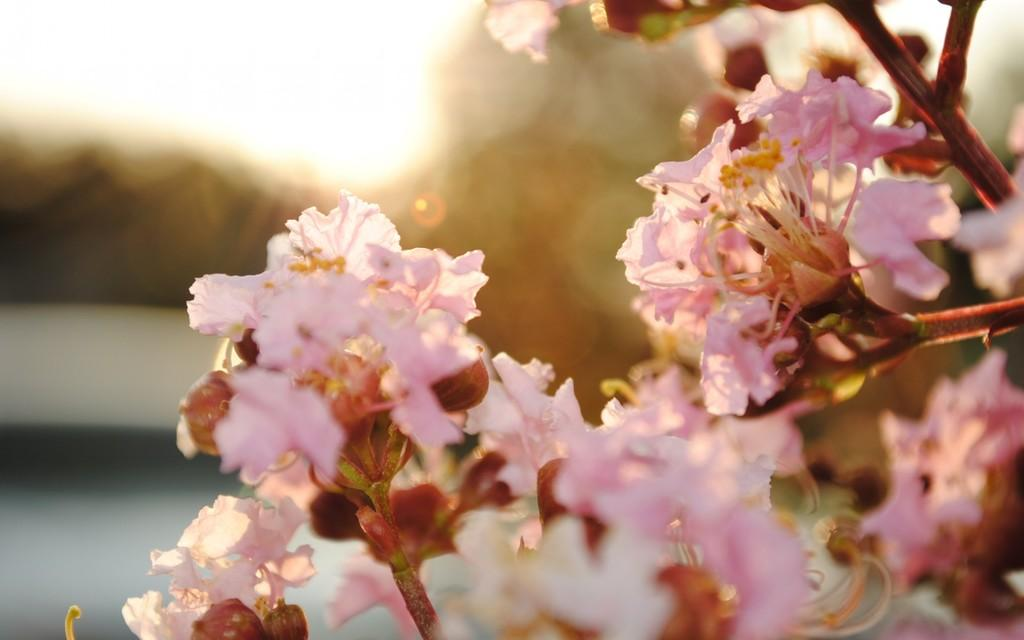Where was the image taken? The image was taken outdoors. What can be seen on the right side of the image? There is a plant with flowers on the right side of the image. What color are the flowers? The flowers are pink in color. What type of beef is being cooked on the grill in the image? There is no grill or beef present in the image; it features a plant with pink flowers. What force is being applied to the animal in the image? There is no animal or force present in the image; it features a plant with pink flowers. 